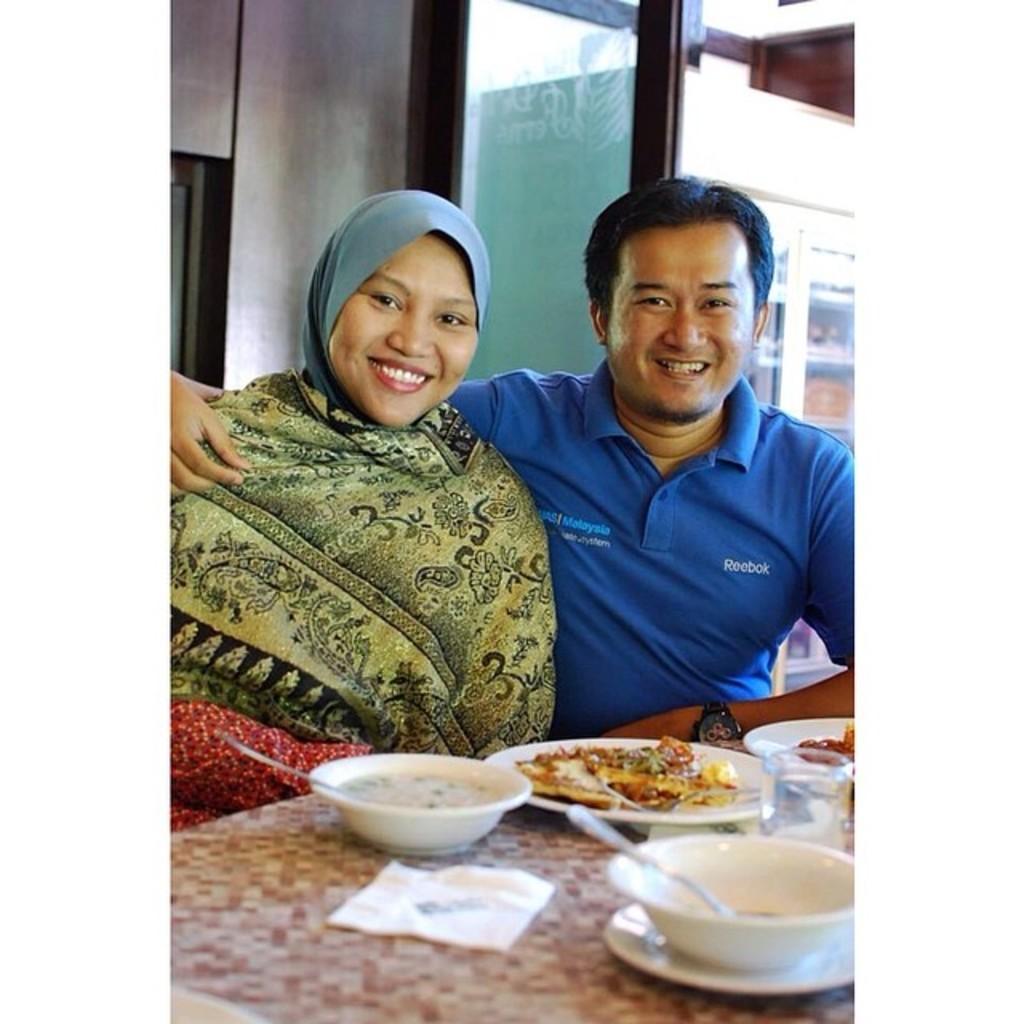Describe this image in one or two sentences. In this image we can see two persons sitting in front of a table. One woman is wearing a headscarf and the person is wearing blue shirt and a watch. On the table we can see group of bowl in which food is placed ,a glass and a tissue paper. In the background we can see door. 